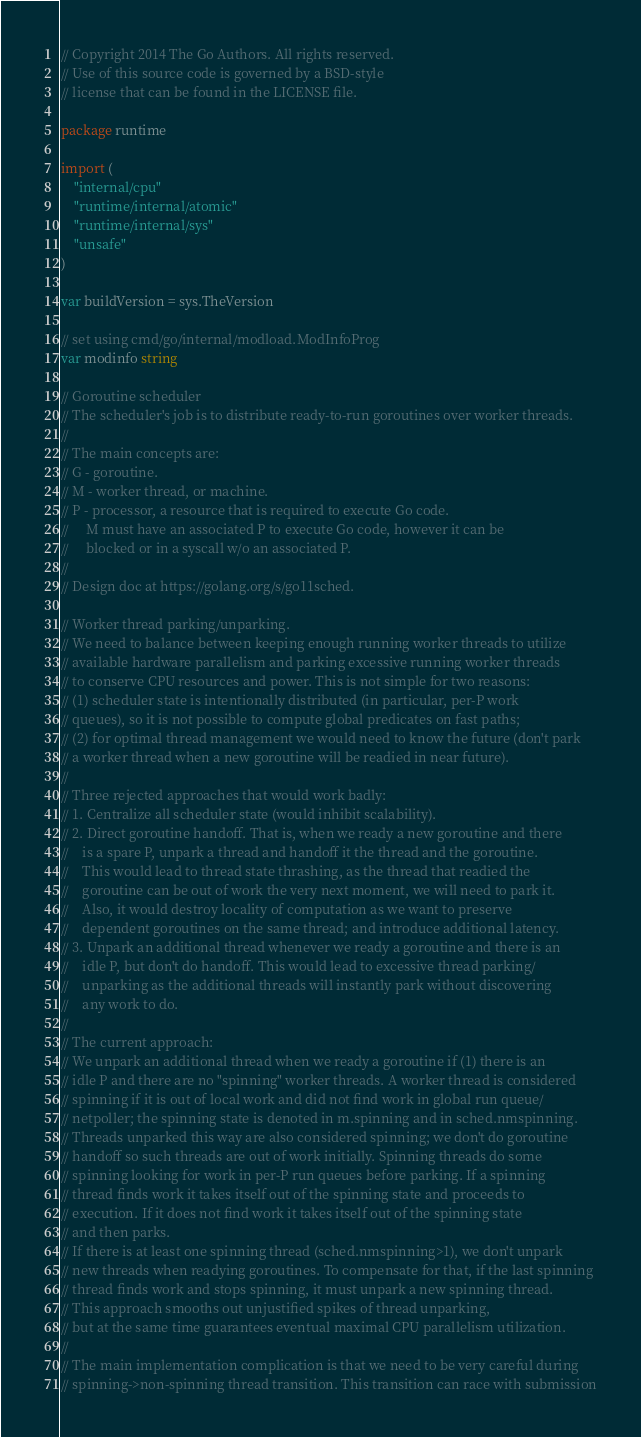<code> <loc_0><loc_0><loc_500><loc_500><_Go_>// Copyright 2014 The Go Authors. All rights reserved.
// Use of this source code is governed by a BSD-style
// license that can be found in the LICENSE file.

package runtime

import (
	"internal/cpu"
	"runtime/internal/atomic"
	"runtime/internal/sys"
	"unsafe"
)

var buildVersion = sys.TheVersion

// set using cmd/go/internal/modload.ModInfoProg
var modinfo string

// Goroutine scheduler
// The scheduler's job is to distribute ready-to-run goroutines over worker threads.
//
// The main concepts are:
// G - goroutine.
// M - worker thread, or machine.
// P - processor, a resource that is required to execute Go code.
//     M must have an associated P to execute Go code, however it can be
//     blocked or in a syscall w/o an associated P.
//
// Design doc at https://golang.org/s/go11sched.

// Worker thread parking/unparking.
// We need to balance between keeping enough running worker threads to utilize
// available hardware parallelism and parking excessive running worker threads
// to conserve CPU resources and power. This is not simple for two reasons:
// (1) scheduler state is intentionally distributed (in particular, per-P work
// queues), so it is not possible to compute global predicates on fast paths;
// (2) for optimal thread management we would need to know the future (don't park
// a worker thread when a new goroutine will be readied in near future).
//
// Three rejected approaches that would work badly:
// 1. Centralize all scheduler state (would inhibit scalability).
// 2. Direct goroutine handoff. That is, when we ready a new goroutine and there
//    is a spare P, unpark a thread and handoff it the thread and the goroutine.
//    This would lead to thread state thrashing, as the thread that readied the
//    goroutine can be out of work the very next moment, we will need to park it.
//    Also, it would destroy locality of computation as we want to preserve
//    dependent goroutines on the same thread; and introduce additional latency.
// 3. Unpark an additional thread whenever we ready a goroutine and there is an
//    idle P, but don't do handoff. This would lead to excessive thread parking/
//    unparking as the additional threads will instantly park without discovering
//    any work to do.
//
// The current approach:
// We unpark an additional thread when we ready a goroutine if (1) there is an
// idle P and there are no "spinning" worker threads. A worker thread is considered
// spinning if it is out of local work and did not find work in global run queue/
// netpoller; the spinning state is denoted in m.spinning and in sched.nmspinning.
// Threads unparked this way are also considered spinning; we don't do goroutine
// handoff so such threads are out of work initially. Spinning threads do some
// spinning looking for work in per-P run queues before parking. If a spinning
// thread finds work it takes itself out of the spinning state and proceeds to
// execution. If it does not find work it takes itself out of the spinning state
// and then parks.
// If there is at least one spinning thread (sched.nmspinning>1), we don't unpark
// new threads when readying goroutines. To compensate for that, if the last spinning
// thread finds work and stops spinning, it must unpark a new spinning thread.
// This approach smooths out unjustified spikes of thread unparking,
// but at the same time guarantees eventual maximal CPU parallelism utilization.
//
// The main implementation complication is that we need to be very careful during
// spinning->non-spinning thread transition. This transition can race with submission</code> 